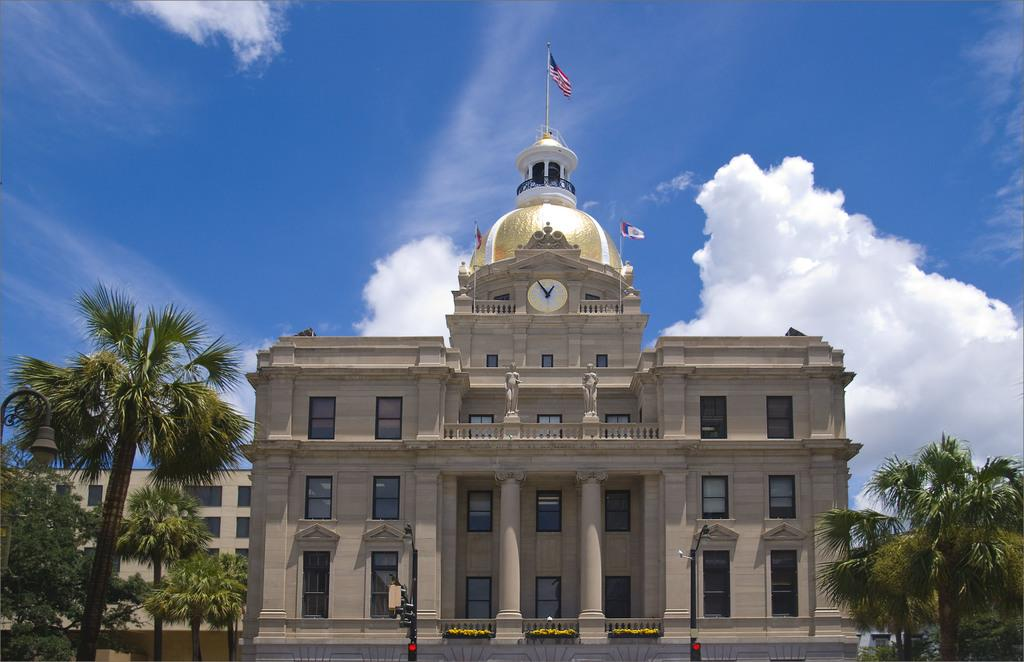What type of structures can be seen in the image? There are buildings in the image. What artistic elements are present in the image? There are sculptures in the image. What type of vegetation is visible in the image? There are trees in the image. What architectural features can be seen in the image? There are pillars in the image. What objects are attached to poles in the image? There are poles with flags and signal lights in the image. What is visible in the background of the image? The sky is visible in the background of the image. What type of tin can be seen in the image? There is no tin present in the image. What is the desire of the ghost in the image? There is no ghost present in the image, so it is not possible to determine its desires. 